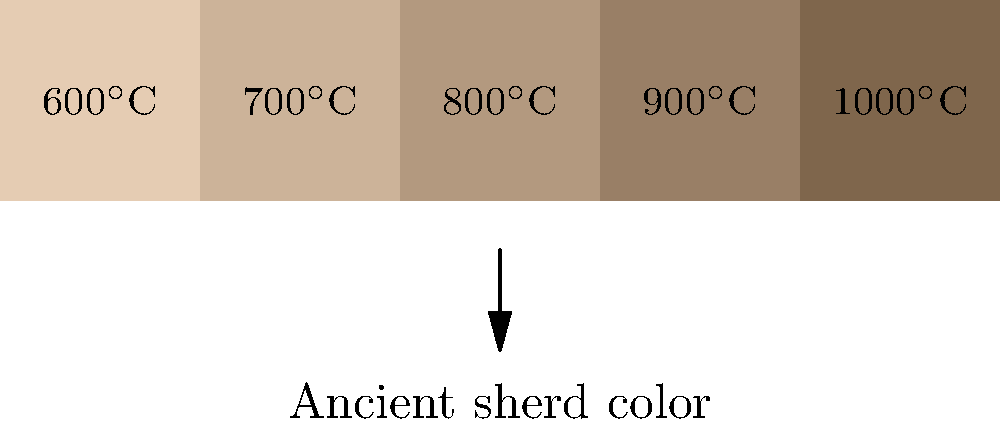Based on the color chart shown, which represents the relationship between firing temperature and ceramic color, what would be the estimated firing temperature of an ancient pottery sherd that closely matches the middle color in the chart? To determine the estimated firing temperature of the ancient pottery sherd, we need to follow these steps:

1. Observe the color chart provided, which shows a range of colors corresponding to different firing temperatures.

2. Note that the chart displays five color gradients, each associated with a specific temperature range.

3. The temperatures increase from left to right, starting at 600°C and incrementing by 100°C for each color.

4. The question asks about the middle color in the chart, which is the third color from the left.

5. Count from left to right:
   - First color: 600°C
   - Second color: 700°C
   - Third color (middle): 800°C
   - Fourth color: 900°C
   - Fifth color: 1000°C

6. The middle color corresponds to a firing temperature of 800°C.

Therefore, if the ancient pottery sherd closely matches the middle color in the chart, its estimated firing temperature would be 800°C.
Answer: 800°C 